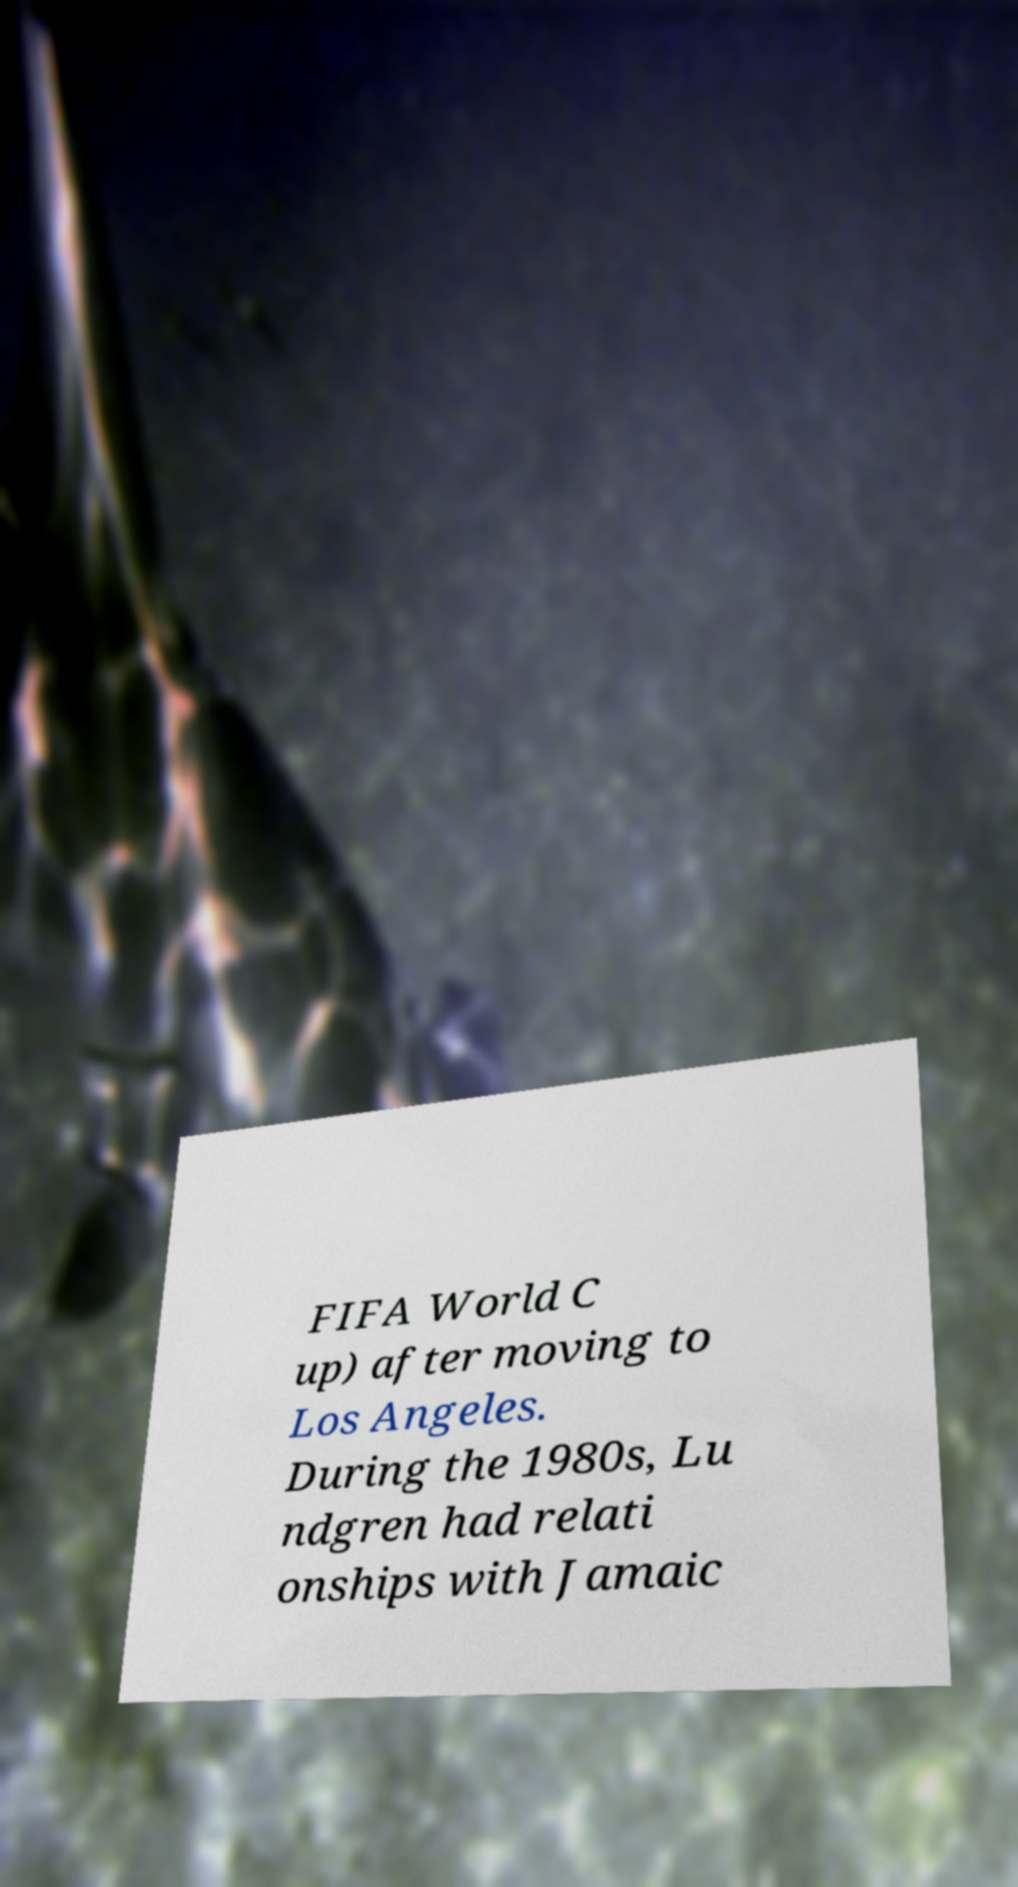Could you assist in decoding the text presented in this image and type it out clearly? FIFA World C up) after moving to Los Angeles. During the 1980s, Lu ndgren had relati onships with Jamaic 